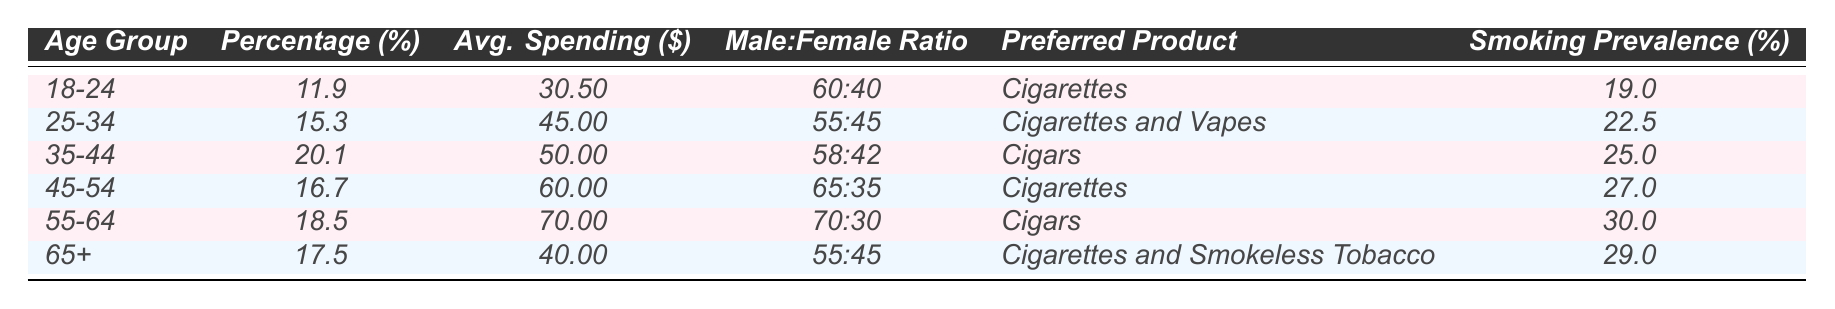What is the preferred tobacco product for the 25-34 age group? The data shows that the preferred product for the 25-34 age group is "Cigarettes and Vapes."
Answer: Cigarettes and Vapes Which age group has the highest smoking prevalence? By comparing the smoking prevalence percentages, the highest is 30.0%, associated with the age group 55-64.
Answer: 55-64 What is the male-to-female ratio for the 45-54 age group? The table specifies that the male-to-female ratio in this age group is 65:35.
Answer: 65:35 What is the average spending of all age groups combined? The average spending can be calculated by summing the individual average spendings: (30.50 + 45.00 + 50.00 + 60.00 + 70.00 + 40.00) = 295.50, then dividing by the number of age groups (6), giving an average of 295.50 / 6 = 49.25.
Answer: 49.25 Is the percentage of tobacco consumers higher in the 35-44 age group compared to the 18-24 age group? The percentage for the 35-44 age group is 20.1% while it is 11.9% for the 18-24 age group, indicating that it is indeed higher.
Answer: Yes What is the total percentage of tobacco consumers in the age groups 18-24 and 25-34 combined? Adding the percentages: 11.9% (18-24) + 15.3% (25-34) equals 27.2%.
Answer: 27.2% What product do the 65+ age group prefer the most? The 65+ age group prefers "Cigarettes and Smokeless Tobacco" according to the table.
Answer: Cigarettes and Smokeless Tobacco Is the average spending more than 50 dollars for the 35-44 age group? The average spending for the 35-44 age group is 50.00 dollars, which is not more than 50.
Answer: No Which age group spends the most on tobacco products? The data shows that the 55-64 age group spends the most on tobacco products, at 70.00 dollars on average.
Answer: 55-64 How does the smoking prevalence of the 45-54 age group compare to the 65+ age group? The 45-54 age group has a smoking prevalence of 27.0%, while the 65+ age group has 29.0%, making the 65+ age group higher.
Answer: 65+ is higher 